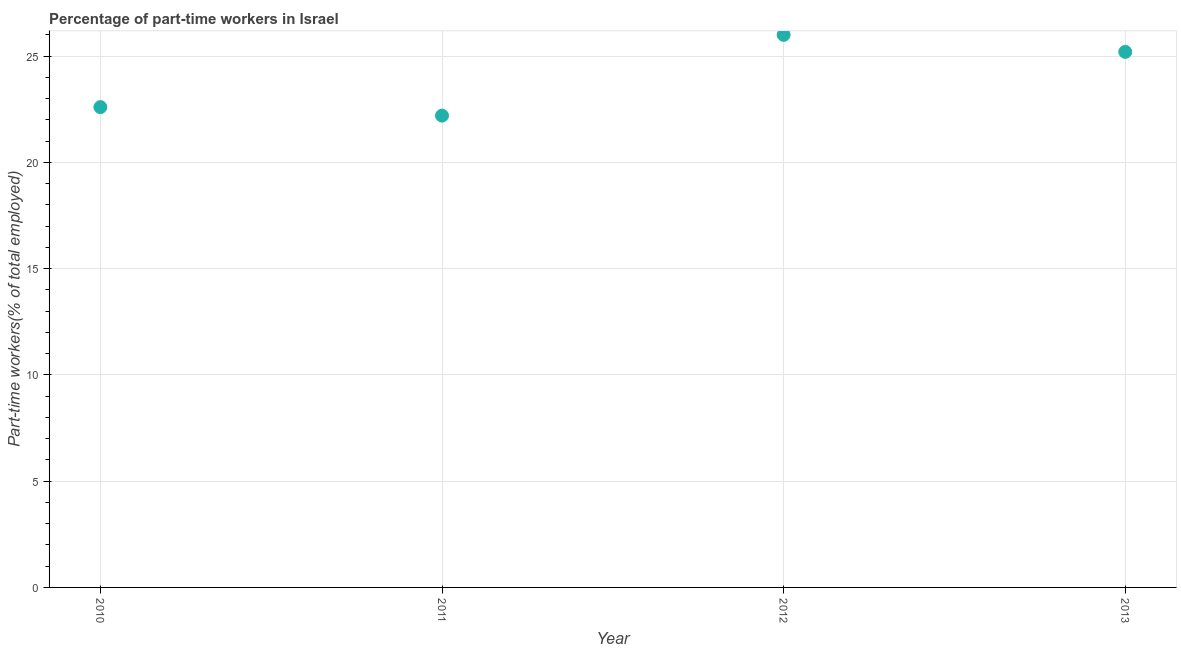What is the percentage of part-time workers in 2013?
Give a very brief answer. 25.2. Across all years, what is the minimum percentage of part-time workers?
Your answer should be compact. 22.2. In which year was the percentage of part-time workers minimum?
Your response must be concise. 2011. What is the sum of the percentage of part-time workers?
Offer a very short reply. 96. What is the difference between the percentage of part-time workers in 2010 and 2013?
Your answer should be very brief. -2.6. What is the average percentage of part-time workers per year?
Keep it short and to the point. 24. What is the median percentage of part-time workers?
Ensure brevity in your answer.  23.9. In how many years, is the percentage of part-time workers greater than 15 %?
Keep it short and to the point. 4. What is the ratio of the percentage of part-time workers in 2012 to that in 2013?
Your response must be concise. 1.03. Is the difference between the percentage of part-time workers in 2010 and 2013 greater than the difference between any two years?
Offer a very short reply. No. What is the difference between the highest and the second highest percentage of part-time workers?
Provide a succinct answer. 0.8. What is the difference between the highest and the lowest percentage of part-time workers?
Provide a succinct answer. 3.8. How many dotlines are there?
Your answer should be very brief. 1. How many years are there in the graph?
Ensure brevity in your answer.  4. What is the difference between two consecutive major ticks on the Y-axis?
Keep it short and to the point. 5. Are the values on the major ticks of Y-axis written in scientific E-notation?
Offer a very short reply. No. Does the graph contain any zero values?
Keep it short and to the point. No. Does the graph contain grids?
Provide a succinct answer. Yes. What is the title of the graph?
Give a very brief answer. Percentage of part-time workers in Israel. What is the label or title of the Y-axis?
Offer a very short reply. Part-time workers(% of total employed). What is the Part-time workers(% of total employed) in 2010?
Ensure brevity in your answer.  22.6. What is the Part-time workers(% of total employed) in 2011?
Offer a terse response. 22.2. What is the Part-time workers(% of total employed) in 2012?
Provide a succinct answer. 26. What is the Part-time workers(% of total employed) in 2013?
Keep it short and to the point. 25.2. What is the difference between the Part-time workers(% of total employed) in 2010 and 2011?
Your response must be concise. 0.4. What is the difference between the Part-time workers(% of total employed) in 2010 and 2013?
Your response must be concise. -2.6. What is the difference between the Part-time workers(% of total employed) in 2011 and 2012?
Provide a short and direct response. -3.8. What is the difference between the Part-time workers(% of total employed) in 2011 and 2013?
Give a very brief answer. -3. What is the ratio of the Part-time workers(% of total employed) in 2010 to that in 2012?
Offer a terse response. 0.87. What is the ratio of the Part-time workers(% of total employed) in 2010 to that in 2013?
Make the answer very short. 0.9. What is the ratio of the Part-time workers(% of total employed) in 2011 to that in 2012?
Provide a succinct answer. 0.85. What is the ratio of the Part-time workers(% of total employed) in 2011 to that in 2013?
Your answer should be compact. 0.88. What is the ratio of the Part-time workers(% of total employed) in 2012 to that in 2013?
Give a very brief answer. 1.03. 